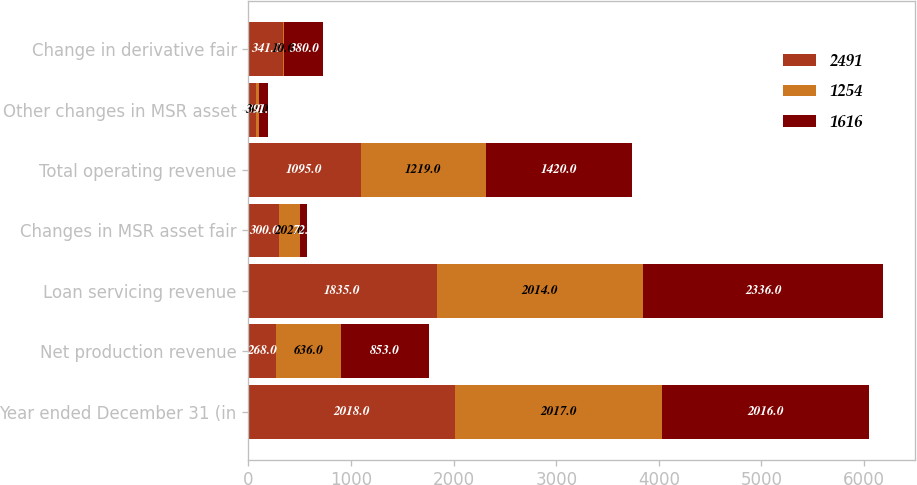<chart> <loc_0><loc_0><loc_500><loc_500><stacked_bar_chart><ecel><fcel>Year ended December 31 (in<fcel>Net production revenue<fcel>Loan servicing revenue<fcel>Changes in MSR asset fair<fcel>Total operating revenue<fcel>Other changes in MSR asset<fcel>Change in derivative fair<nl><fcel>2491<fcel>2018<fcel>268<fcel>1835<fcel>300<fcel>1095<fcel>70<fcel>341<nl><fcel>1254<fcel>2017<fcel>636<fcel>2014<fcel>202<fcel>1219<fcel>30<fcel>10<nl><fcel>1616<fcel>2016<fcel>853<fcel>2336<fcel>72<fcel>1420<fcel>91<fcel>380<nl></chart> 